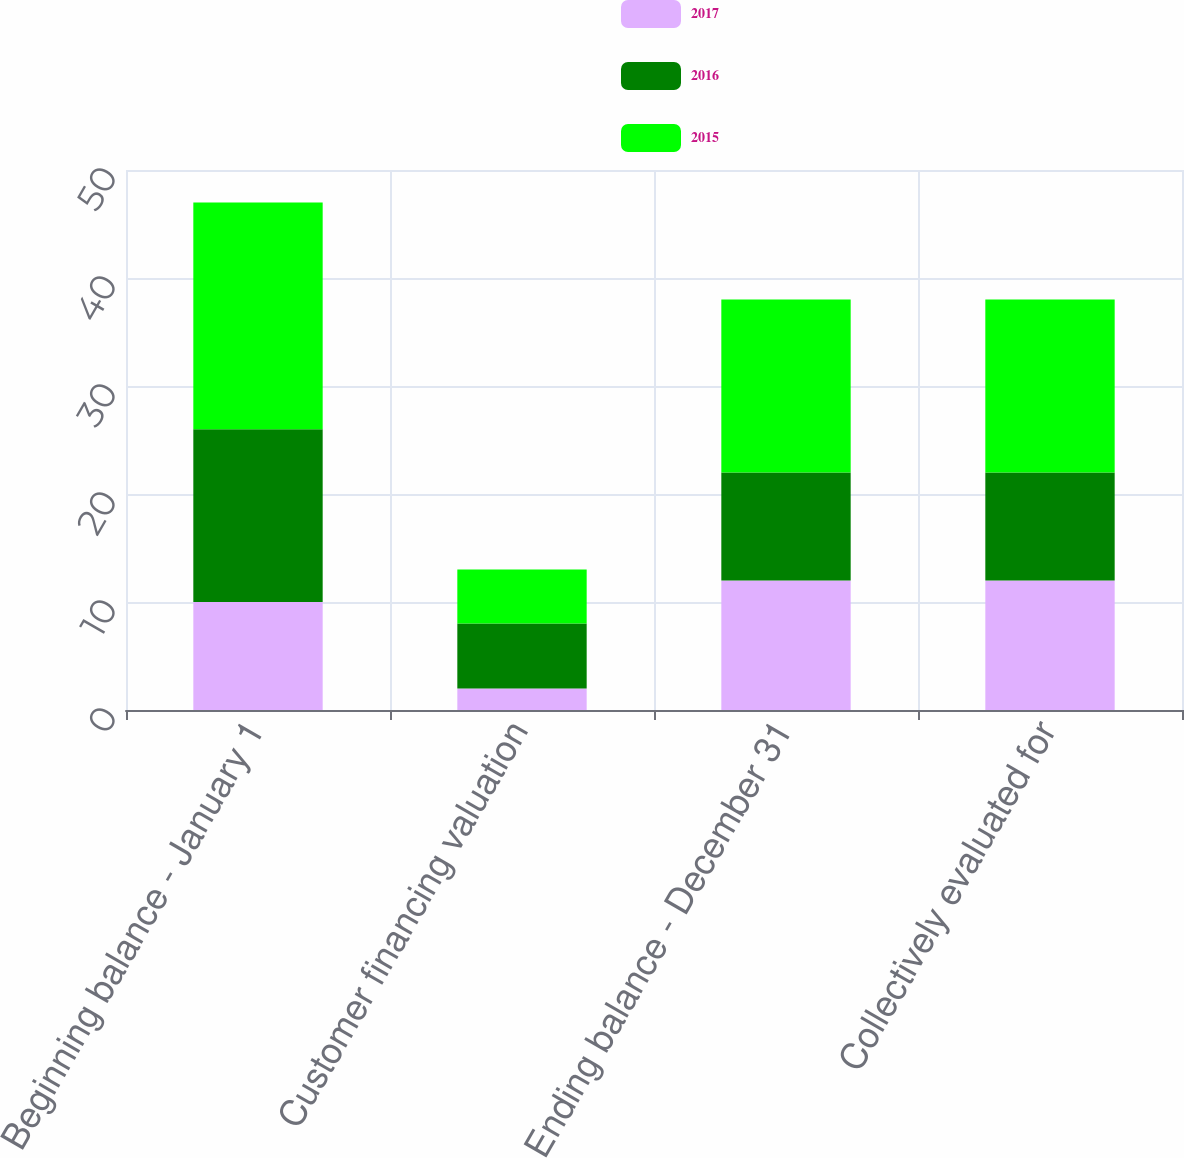Convert chart to OTSL. <chart><loc_0><loc_0><loc_500><loc_500><stacked_bar_chart><ecel><fcel>Beginning balance - January 1<fcel>Customer financing valuation<fcel>Ending balance - December 31<fcel>Collectively evaluated for<nl><fcel>2017<fcel>10<fcel>2<fcel>12<fcel>12<nl><fcel>2016<fcel>16<fcel>6<fcel>10<fcel>10<nl><fcel>2015<fcel>21<fcel>5<fcel>16<fcel>16<nl></chart> 